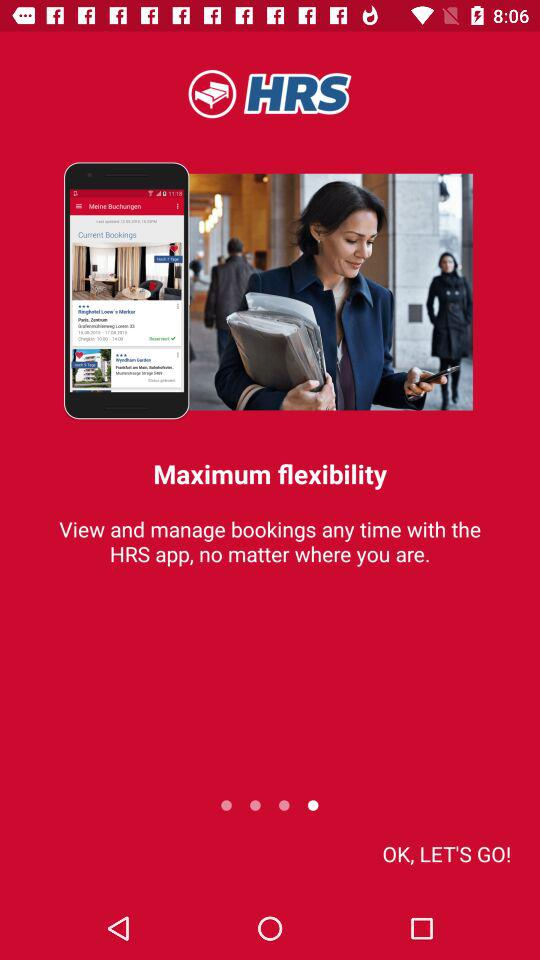What is the app name? The app name is "HRS". 